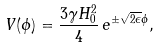<formula> <loc_0><loc_0><loc_500><loc_500>V ( \phi ) = \frac { 3 \gamma H _ { 0 } ^ { 2 } } { 4 } \, e ^ { \pm \sqrt { 2 \epsilon } \phi } ,</formula> 